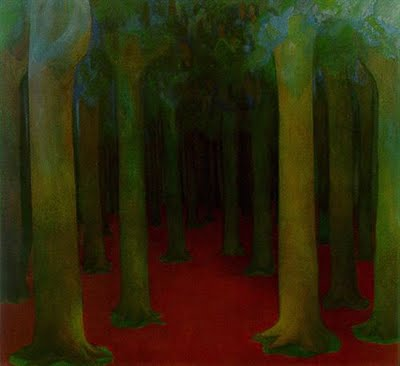How does the impressionistic style influence the viewer's perception of this forest scene? The impressionistic style of the painting, characterized by its loose brushwork and emphasis on light and color over detail, plays a crucial role in shaping the viewer's perception. This artistic technique allows the scene to appear more vibrant and dynamic, suggesting movement and life within the forest. It also creates a dreamlike, almost ethereal quality, encouraging the viewer to engage more with their imagination and personal interpretation of the scene. This style can make the forest seem more mysterious and inviting, prompting an emotional rather than analytical response to the artwork. 